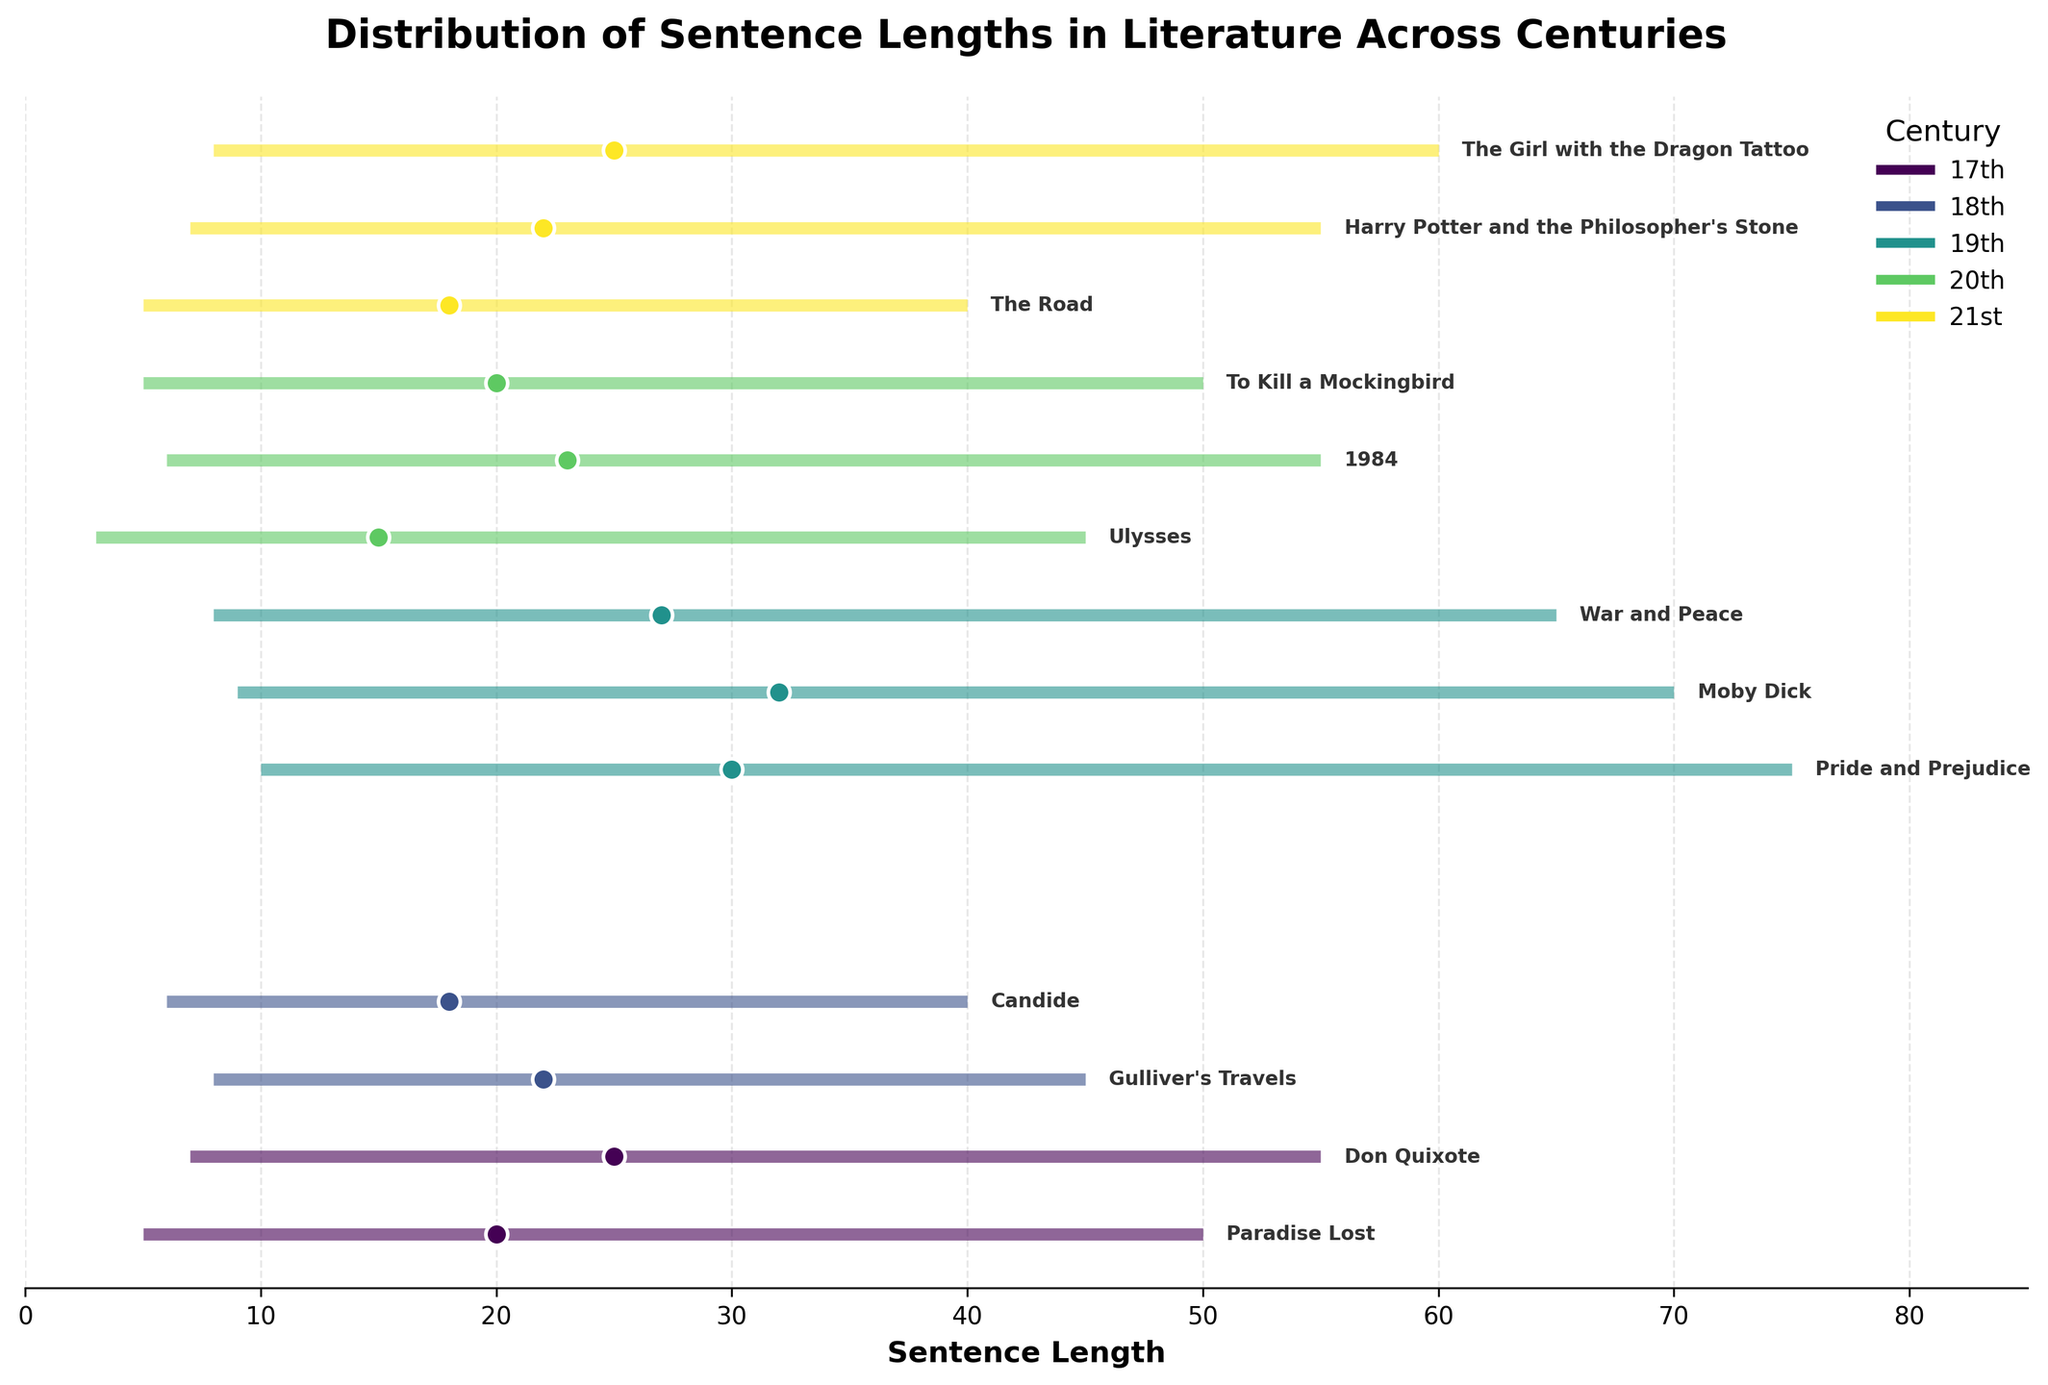What is the title of the figure? The title is usually located at the top of the figure, summarizing its content. Here, it indicates the overall topic of the graph: "Distribution of Sentence Lengths in Literature Across Centuries."
Answer: Distribution of Sentence Lengths in Literature Across Centuries Which century has the work with the longest maximum sentence length? By examining the maximum sentence lengths for each work, we see that "Pride and Prejudice" from the 19th century has the longest maximum sentence length of 75.
Answer: 19th century What is the average sentence length of "1984"? We look for "1984" on the plot and observe its corresponding position along the x-axis to find its average sentence length.
Answer: 23 Which works have a minimum sentence length of 8 words? We identify works with a minimum value of 8 on the x-axis. From the plot, these are "Gulliver's Travels," "War and Peace," and "The Girl with the Dragon Tattoo."
Answer: Gulliver's Travels, War and Peace, The Girl with the Dragon Tattoo Is the average sentence length of "Moby Dick" greater than "Paradise Lost"? We compare the average sentence lengths on the x-axis. "Moby Dick" has an average of 32, and "Paradise Lost" has an average of 20. Hence, "Moby Dick" is greater.
Answer: Yes What is the range of sentence lengths for "To Kill a Mockingbird"? The range is the difference between the maximum and minimum sentence lengths. For "To Kill a Mockingbird," it's 50 - 5 = 45.
Answer: 45 Which century has the most consistent sentence lengths across its works (smallest range variation)? We examine the length of the horizontal lines. The 21st century has relatively shorter lines, indicating less variation.
Answer: 21st century In which century do we find the least variance in maximum sentence lengths across its works? By visually assessing the length of the horizontal lines representing maximum ranges, the 17th century has more consistent maximum lengths across its works.
Answer: 17th century Compare the average sentence lengths between "Ulysses" and "The Road." Which has shorter average sentences? "Ulysses" has an average of 15, whereas "The Road" has an average of 18. Thus, "Ulysses" has the shorter average.
Answer: Ulysses How does the sentence length distribution of "Don Quixote" compare to "Candide"? "Don Quixote" has a range of 7 to 55 and an average of 25, while "Candide" has a range of 6 to 40 and an average of 18. "Don Quixote" has longer sentences on both ends and a greater average.
Answer: Don Quixote has longer sentences 